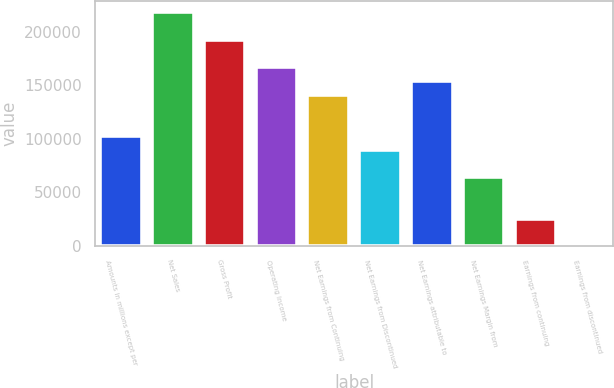<chart> <loc_0><loc_0><loc_500><loc_500><bar_chart><fcel>Amounts in millions except per<fcel>Net Sales<fcel>Gross Profit<fcel>Operating Income<fcel>Net Earnings from Continuing<fcel>Net Earnings from Discontinued<fcel>Net Earnings attributable to<fcel>Net Earnings Margin from<fcel>Earnings from continuing<fcel>Earnings from discontinued<nl><fcel>102538<fcel>217892<fcel>192258<fcel>166623<fcel>140989<fcel>89720.6<fcel>153806<fcel>64086.3<fcel>25635<fcel>0.69<nl></chart> 